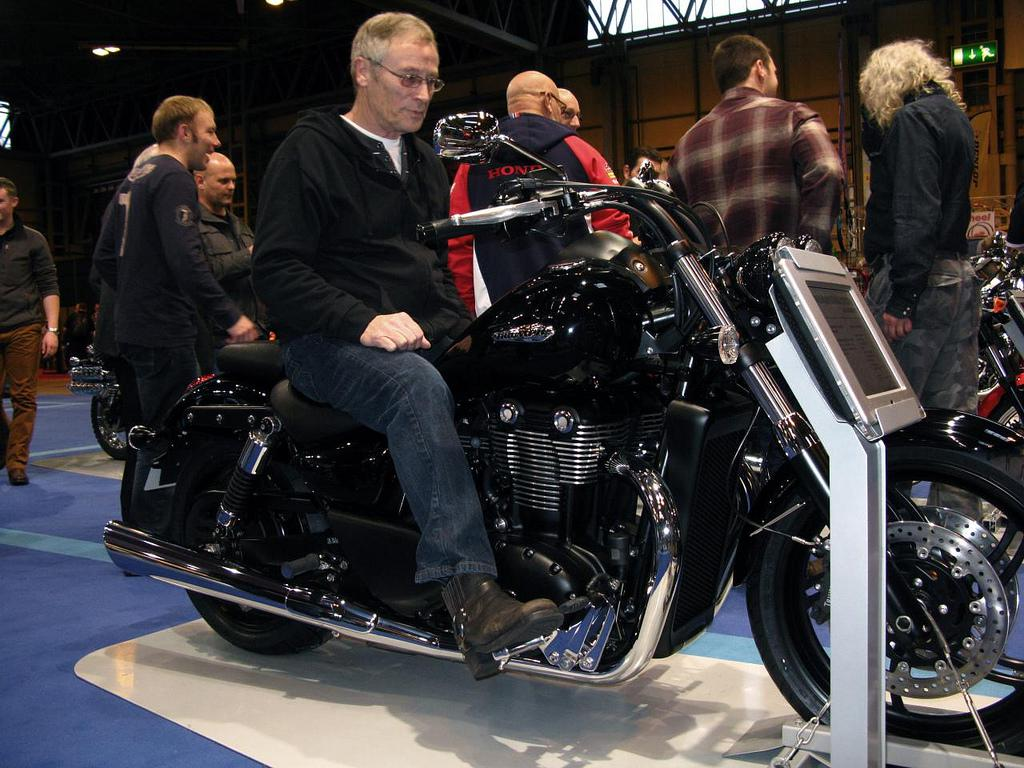Question: who has their name on the bald man's sweater?
Choices:
A. Michael Jordan.
B. Nike.
C. Honda.
D. Obama.
Answer with the letter. Answer: C Question: what makes the metal shine?
Choices:
A. Glitter.
B. Chrome.
C. Rhinestones.
D. An inner light.
Answer with the letter. Answer: B Question: what helps a driver see behind them when they are driving?
Choices:
A. Other passengers.
B. A mirror.
C. Turning his head.
D. Eyes in the back of his head.
Answer with the letter. Answer: B Question: what makes spins and touches the road when driving?
Choices:
A. The wheels.
B. Gravel.
C. Landing gear.
D. Fred Flintstone's feet.
Answer with the letter. Answer: A Question: where does one put their hands while driving a motorcycle?
Choices:
A. On the seat.
B. On the person in front.
C. On the handlebars.
D. On the grips.
Answer with the letter. Answer: C Question: how does the motorcycle stop?
Choices:
A. The brakes.
B. Feet.
C. Wrecking.
D. Coasting to a stop.
Answer with the letter. Answer: A Question: where was the picture taken?
Choices:
A. Auto show.
B. Fashion show.
C. Motorcycle show.
D. Computer expo.
Answer with the letter. Answer: C Question: what indicates the emergency exit?
Choices:
A. A Red Lettered sign.
B. Sign by a door.
C. A green and white sign.
D. A lighted sign.
Answer with the letter. Answer: C Question: where are most of the people?
Choices:
A. In the park.
B. In the showroom.
C. At the game.
D. On vacation.
Answer with the letter. Answer: B Question: what is the man wearing?
Choices:
A. A blue ball cap.
B. Glasses.
C. A green shirt.
D. White sneakers.
Answer with the letter. Answer: B Question: who is in the picture?
Choices:
A. Children.
B. Women.
C. Men.
D. Families.
Answer with the letter. Answer: C Question: what is cast onto the floor?
Choices:
A. Flowers.
B. Shadows.
C. Food.
D. Money.
Answer with the letter. Answer: B Question: how many people have long wavy blonde hair?
Choices:
A. Two.
B. Three.
C. One.
D. Four.
Answer with the letter. Answer: C Question: what color is the motorcycle?
Choices:
A. Silver.
B. White.
C. Black.
D. Blue.
Answer with the letter. Answer: C Question: who is looking down?
Choices:
A. A woman.
B. The boss.
C. The teacher.
D. The man.
Answer with the letter. Answer: D Question: where is there a lot of chrome?
Choices:
A. On the car.
B. On the bumper.
C. On the rims.
D. On the motorcycle.
Answer with the letter. Answer: D Question: what word is written in red on the back of the man's jacket?
Choices:
A. Honda.
B. The size.
C. A brand.
D. A logo.
Answer with the letter. Answer: A Question: what color pants does the man in the background to the left have on?
Choices:
A. Black.
B. Blue.
C. Brown.
D. Red.
Answer with the letter. Answer: C 